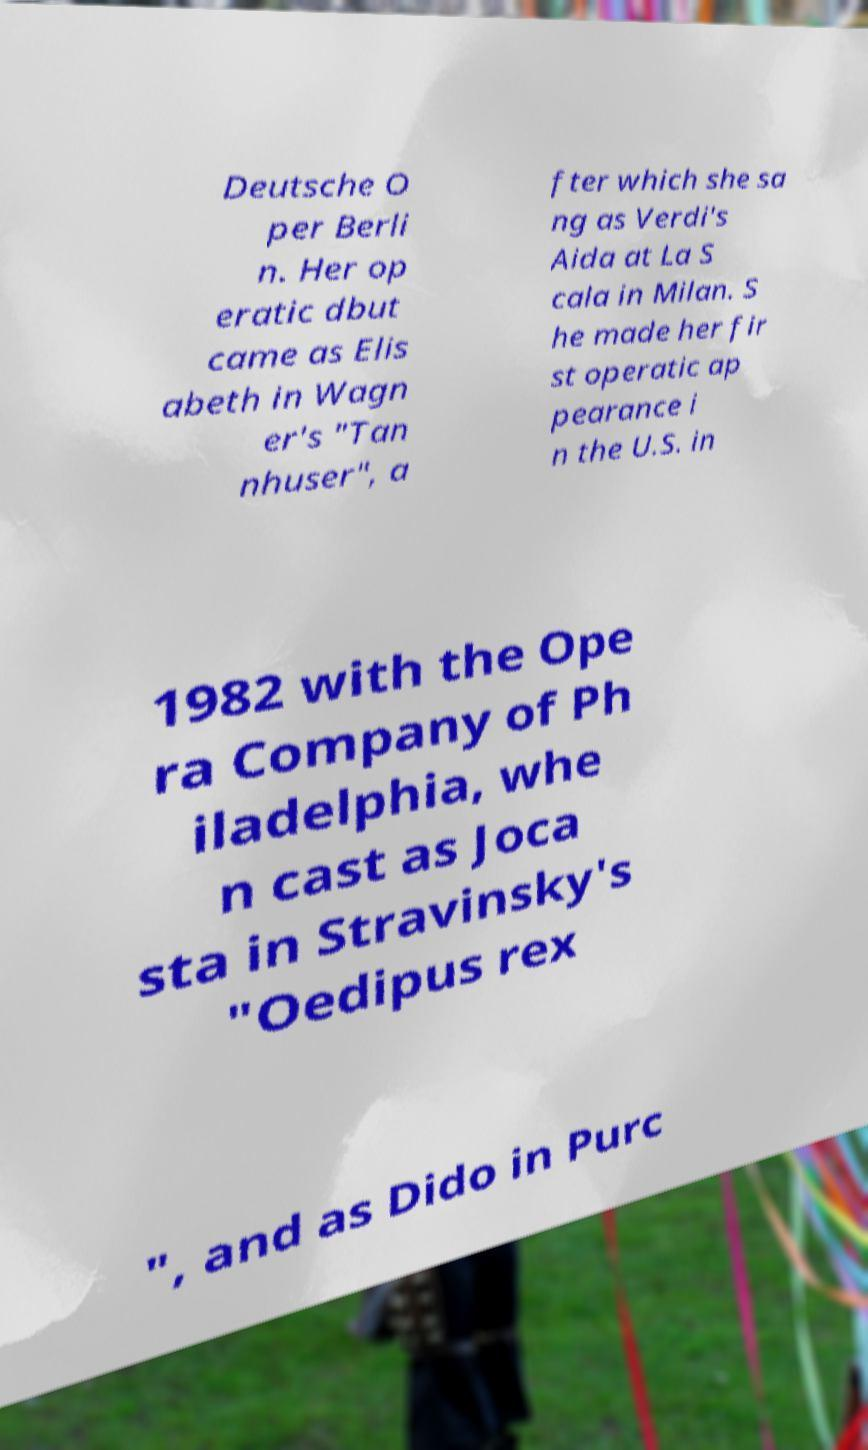Could you extract and type out the text from this image? Deutsche O per Berli n. Her op eratic dbut came as Elis abeth in Wagn er's "Tan nhuser", a fter which she sa ng as Verdi's Aida at La S cala in Milan. S he made her fir st operatic ap pearance i n the U.S. in 1982 with the Ope ra Company of Ph iladelphia, whe n cast as Joca sta in Stravinsky's "Oedipus rex ", and as Dido in Purc 